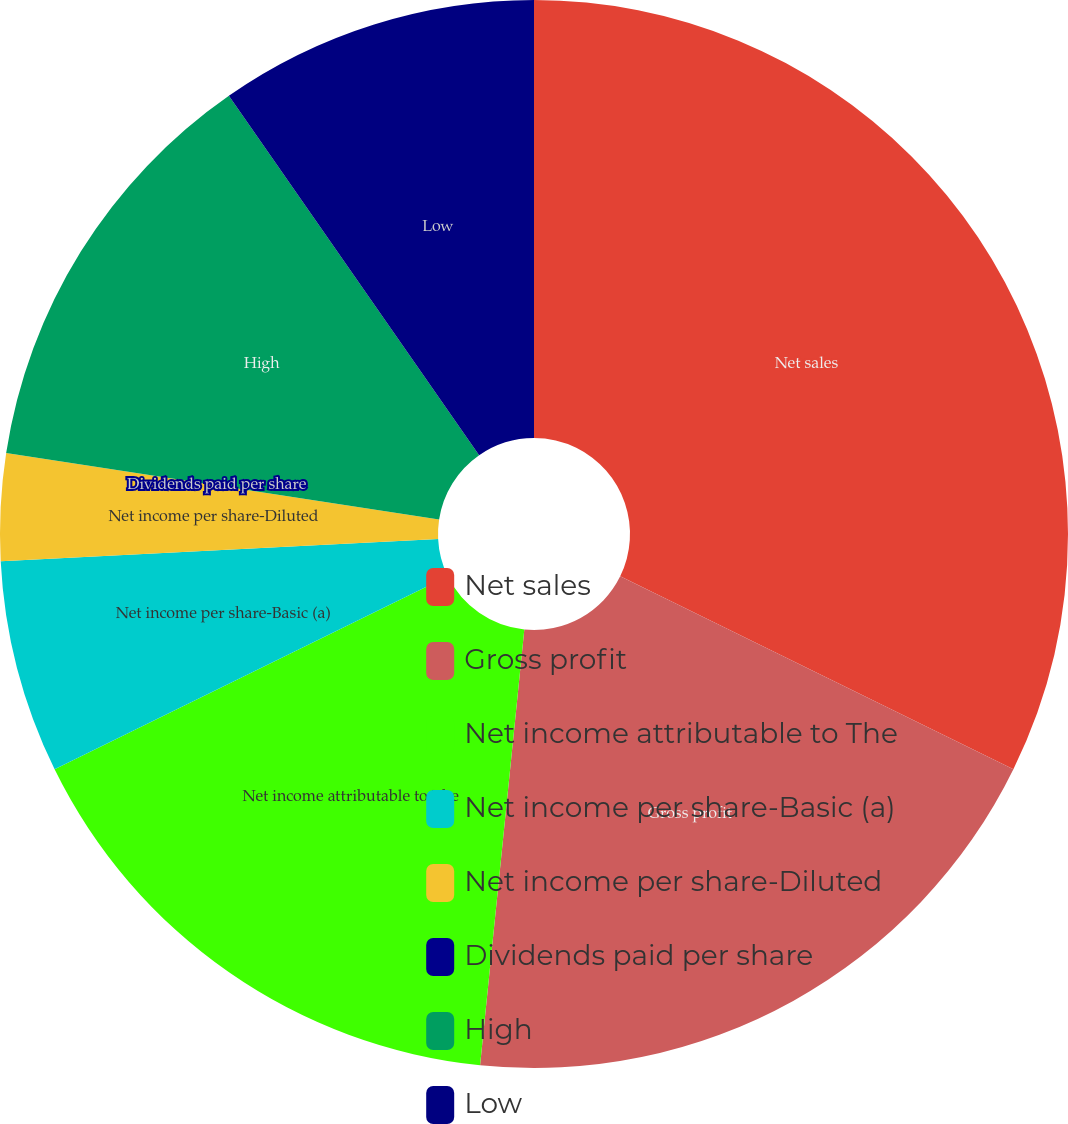Convert chart to OTSL. <chart><loc_0><loc_0><loc_500><loc_500><pie_chart><fcel>Net sales<fcel>Gross profit<fcel>Net income attributable to The<fcel>Net income per share-Basic (a)<fcel>Net income per share-Diluted<fcel>Dividends paid per share<fcel>High<fcel>Low<nl><fcel>32.26%<fcel>19.35%<fcel>16.13%<fcel>6.45%<fcel>3.23%<fcel>0.0%<fcel>12.9%<fcel>9.68%<nl></chart> 